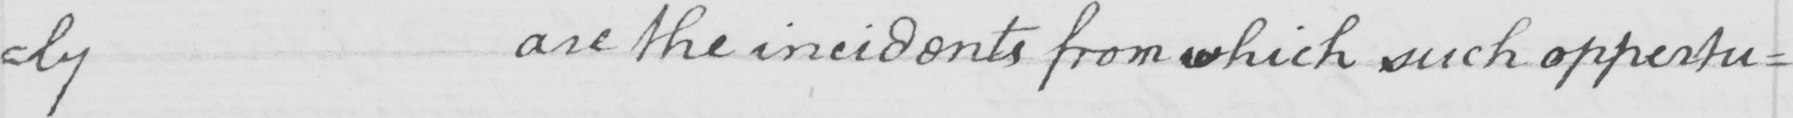What is written in this line of handwriting? ly are the incidents from which such opportu= 